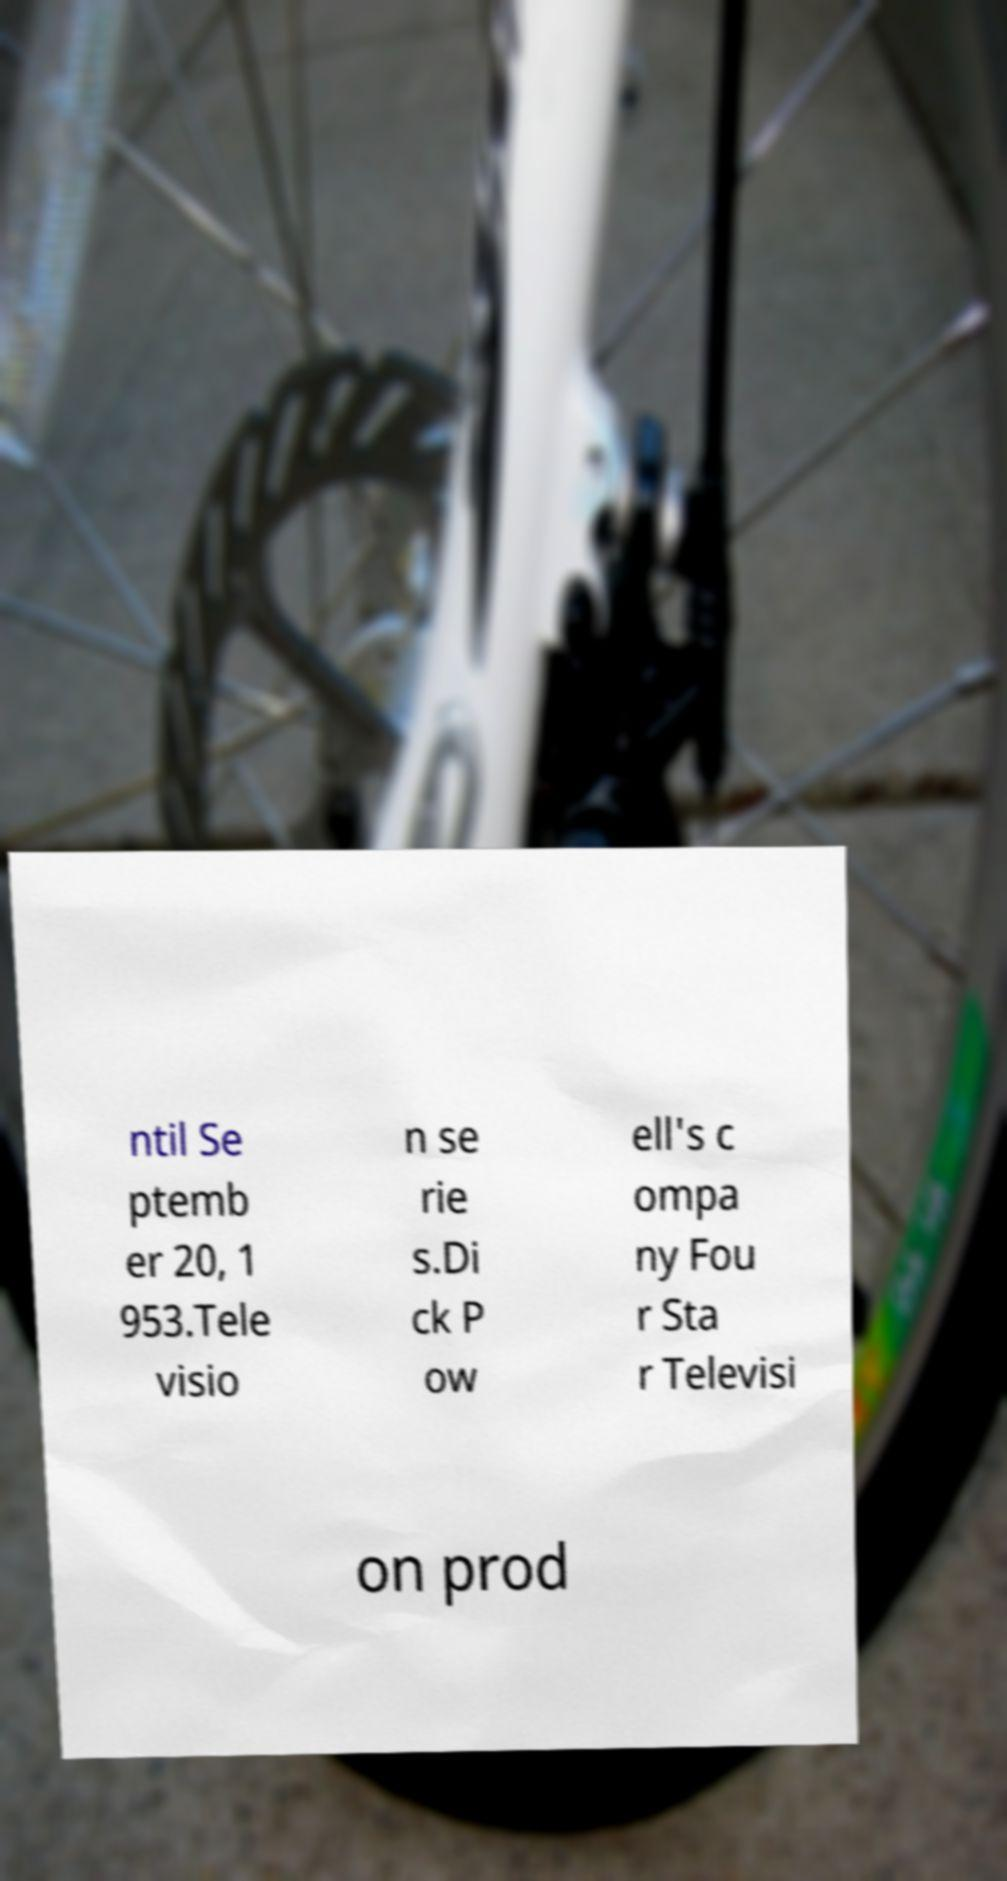There's text embedded in this image that I need extracted. Can you transcribe it verbatim? ntil Se ptemb er 20, 1 953.Tele visio n se rie s.Di ck P ow ell's c ompa ny Fou r Sta r Televisi on prod 